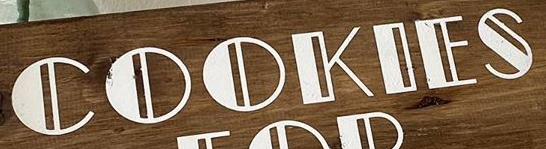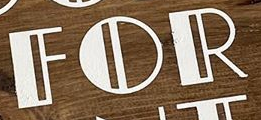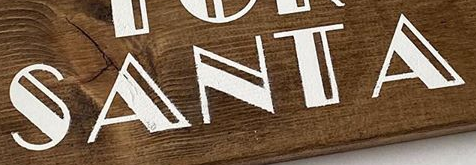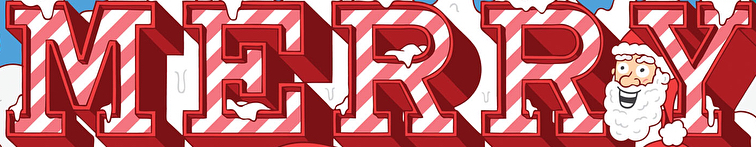What text is displayed in these images sequentially, separated by a semicolon? COOKIES; FOR; SANTA; MERRY 